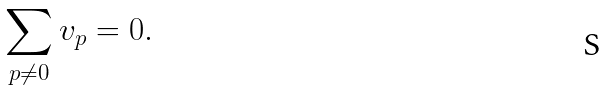<formula> <loc_0><loc_0><loc_500><loc_500>\sum _ { p \neq 0 } v _ { p } = 0 .</formula> 